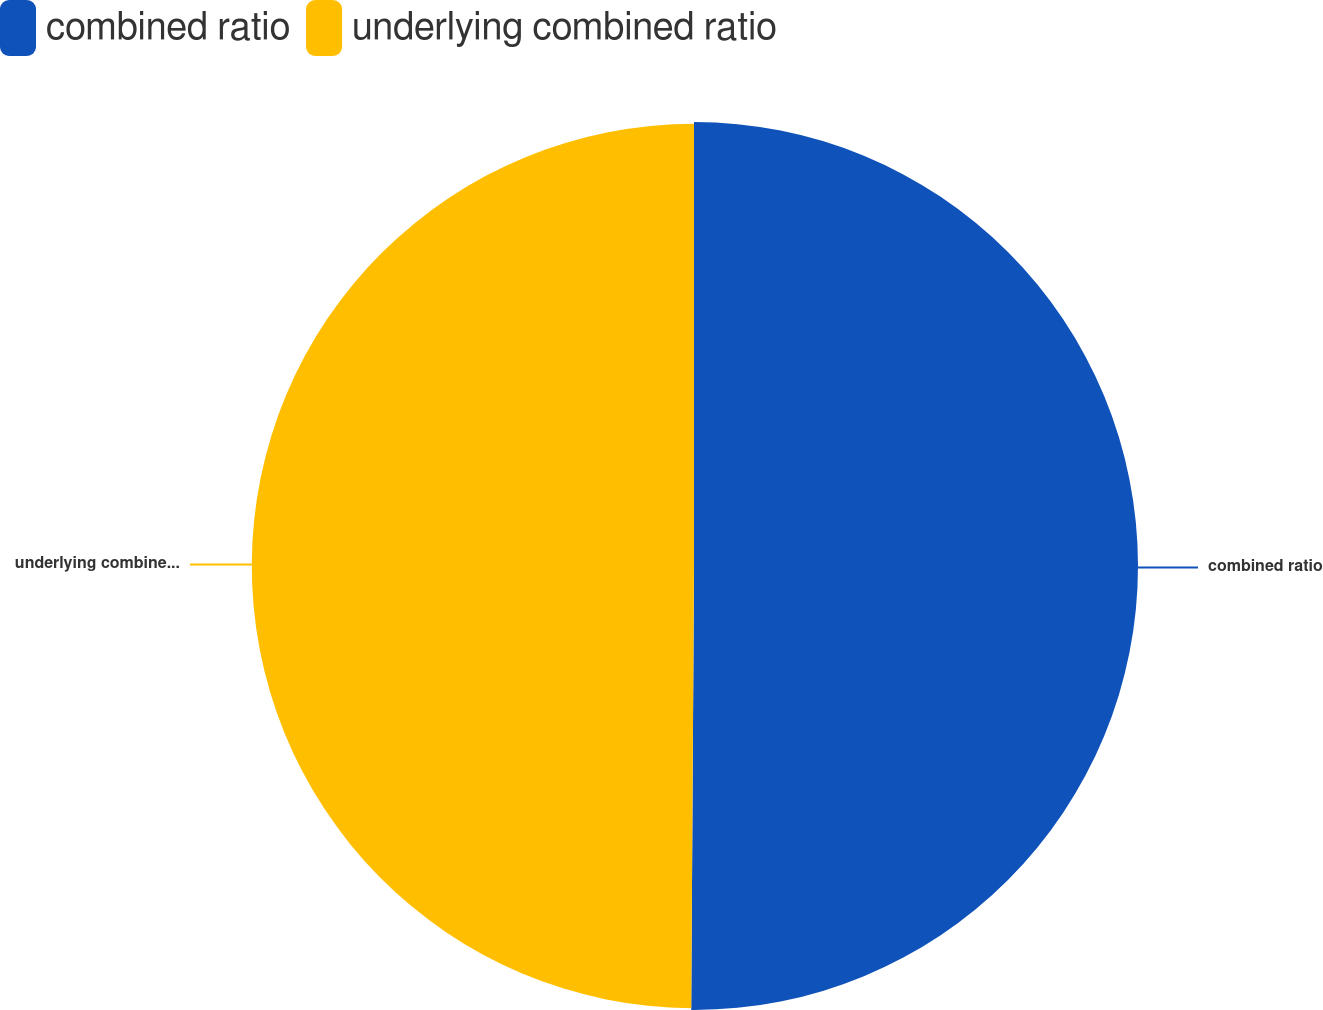Convert chart to OTSL. <chart><loc_0><loc_0><loc_500><loc_500><pie_chart><fcel>combined ratio<fcel>underlying combined ratio<nl><fcel>50.1%<fcel>49.9%<nl></chart> 